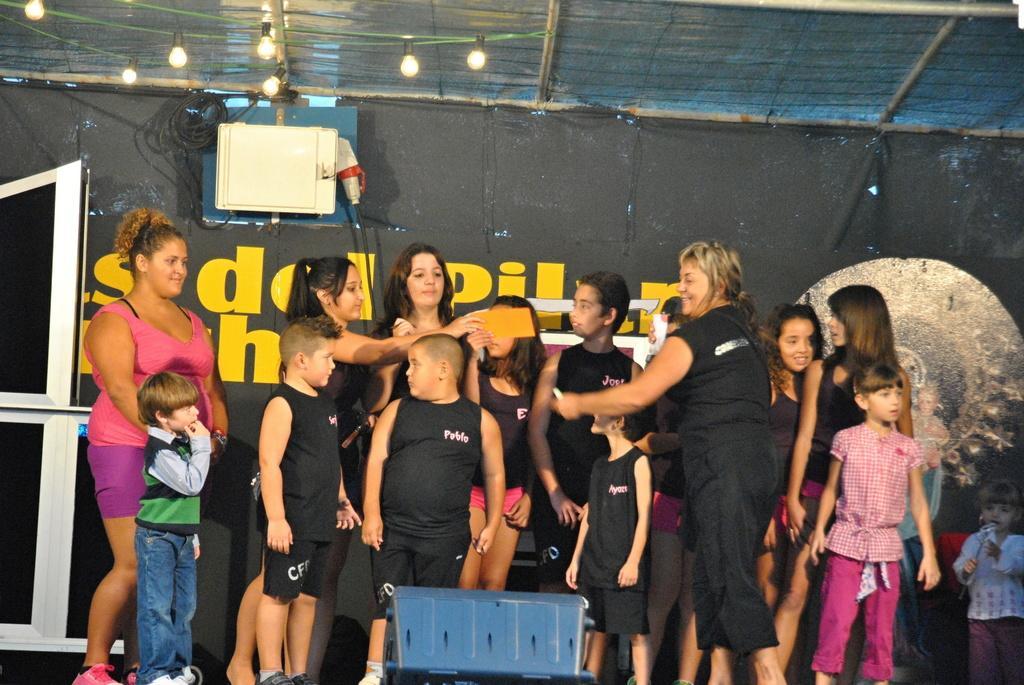Please provide a concise description of this image. There are group of people standing. These are the bulbs, which are hanging to the rope at the top. This looks like a banner. At the bottom of the image, I can see an object, which is blue in color. These are the wires. This looks like an electronic device. 